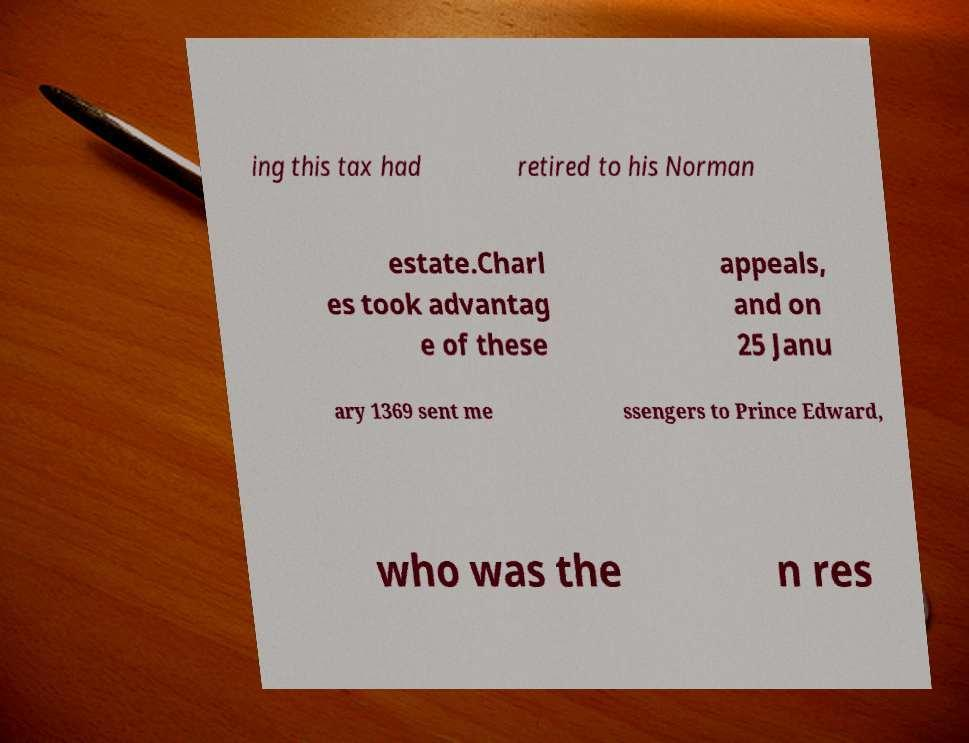Please read and relay the text visible in this image. What does it say? ing this tax had retired to his Norman estate.Charl es took advantag e of these appeals, and on 25 Janu ary 1369 sent me ssengers to Prince Edward, who was the n res 